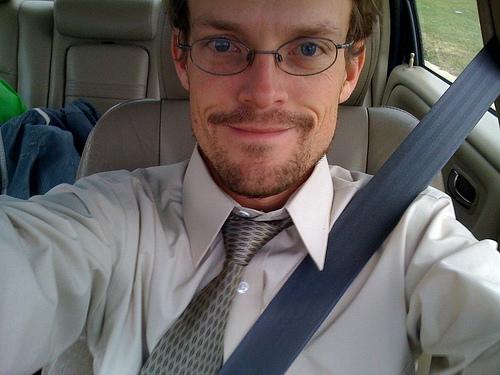Does this man have his seatbelt on?
Give a very brief answer. Yes. Is the man taking a selfie?
Write a very short answer. Yes. What shape are this man's glasses?
Short answer required. Oval. Might this driver be distracted?
Keep it brief. Yes. 